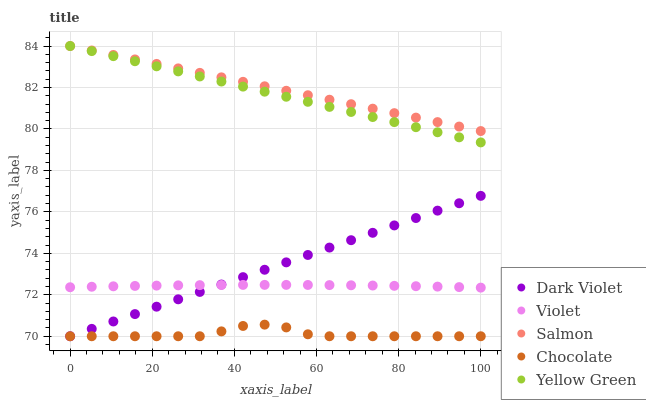Does Chocolate have the minimum area under the curve?
Answer yes or no. Yes. Does Salmon have the maximum area under the curve?
Answer yes or no. Yes. Does Yellow Green have the minimum area under the curve?
Answer yes or no. No. Does Yellow Green have the maximum area under the curve?
Answer yes or no. No. Is Salmon the smoothest?
Answer yes or no. Yes. Is Chocolate the roughest?
Answer yes or no. Yes. Is Yellow Green the smoothest?
Answer yes or no. No. Is Yellow Green the roughest?
Answer yes or no. No. Does Chocolate have the lowest value?
Answer yes or no. Yes. Does Yellow Green have the lowest value?
Answer yes or no. No. Does Yellow Green have the highest value?
Answer yes or no. Yes. Does Dark Violet have the highest value?
Answer yes or no. No. Is Violet less than Yellow Green?
Answer yes or no. Yes. Is Yellow Green greater than Violet?
Answer yes or no. Yes. Does Chocolate intersect Dark Violet?
Answer yes or no. Yes. Is Chocolate less than Dark Violet?
Answer yes or no. No. Is Chocolate greater than Dark Violet?
Answer yes or no. No. Does Violet intersect Yellow Green?
Answer yes or no. No. 